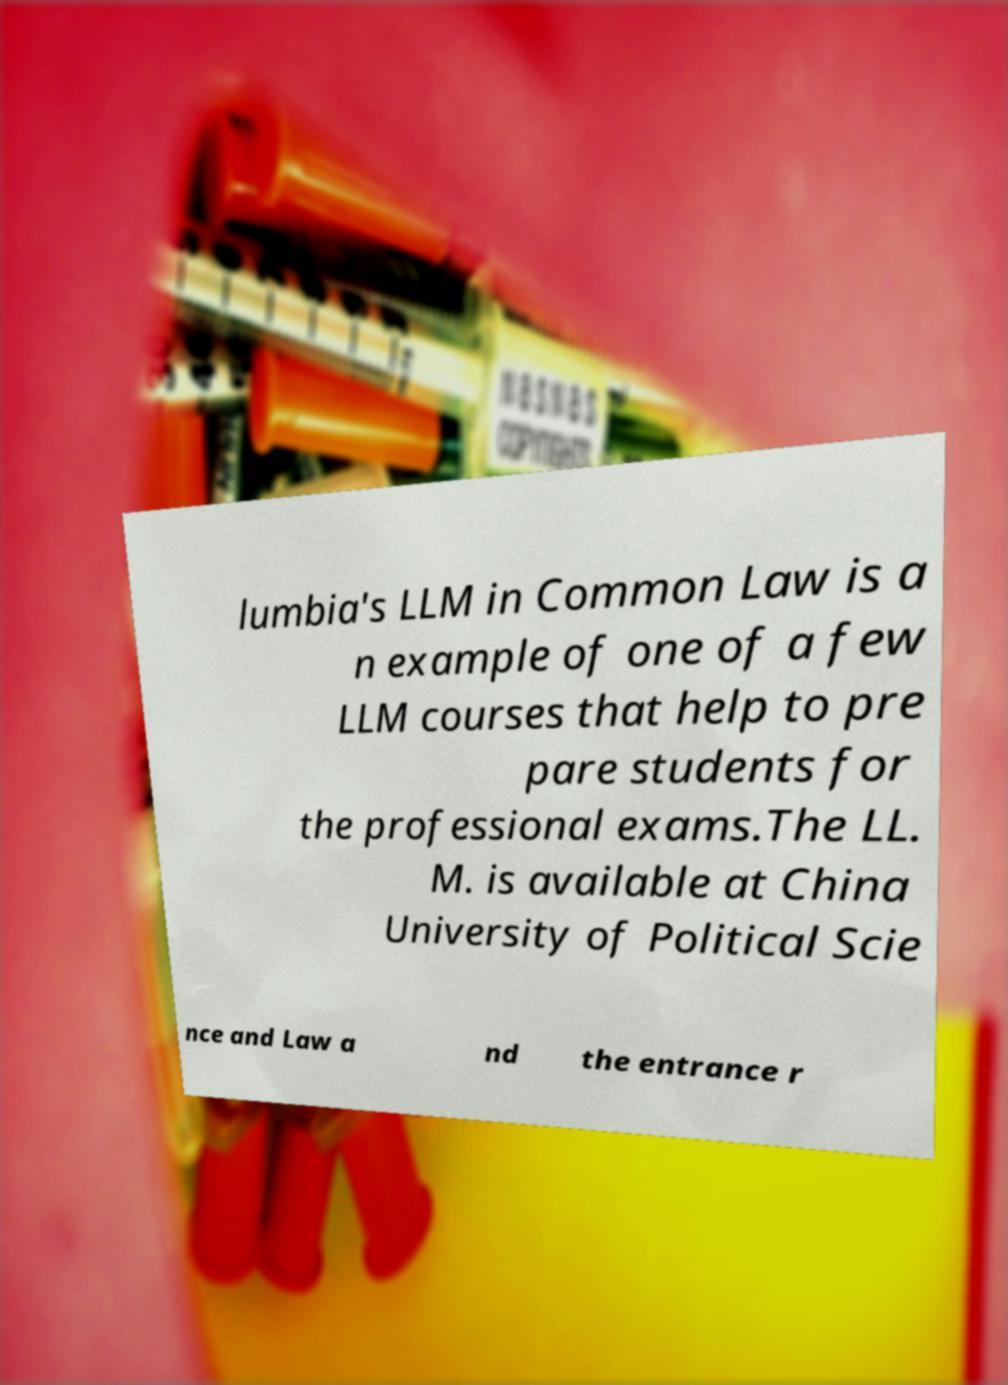I need the written content from this picture converted into text. Can you do that? lumbia's LLM in Common Law is a n example of one of a few LLM courses that help to pre pare students for the professional exams.The LL. M. is available at China University of Political Scie nce and Law a nd the entrance r 